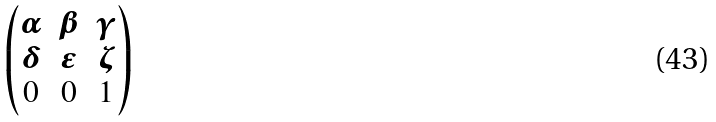<formula> <loc_0><loc_0><loc_500><loc_500>\begin{pmatrix} \alpha & \beta & \gamma \\ \delta & \epsilon & \zeta \\ 0 & 0 & 1 \end{pmatrix}</formula> 